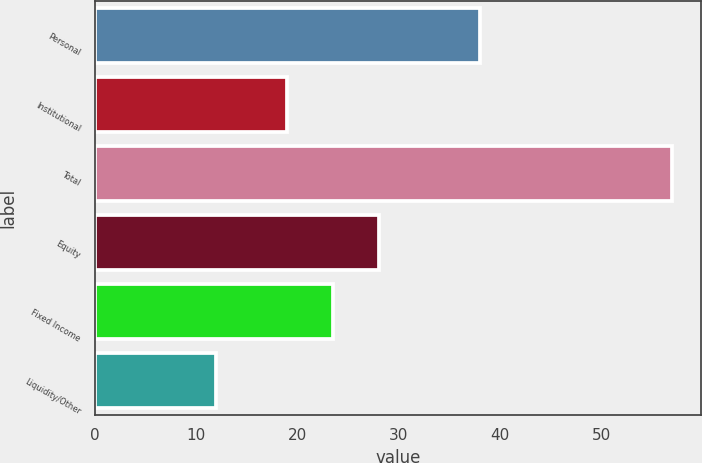<chart> <loc_0><loc_0><loc_500><loc_500><bar_chart><fcel>Personal<fcel>Institutional<fcel>Total<fcel>Equity<fcel>Fixed Income<fcel>Liquidity/Other<nl><fcel>38<fcel>19<fcel>57<fcel>28<fcel>23.5<fcel>12<nl></chart> 